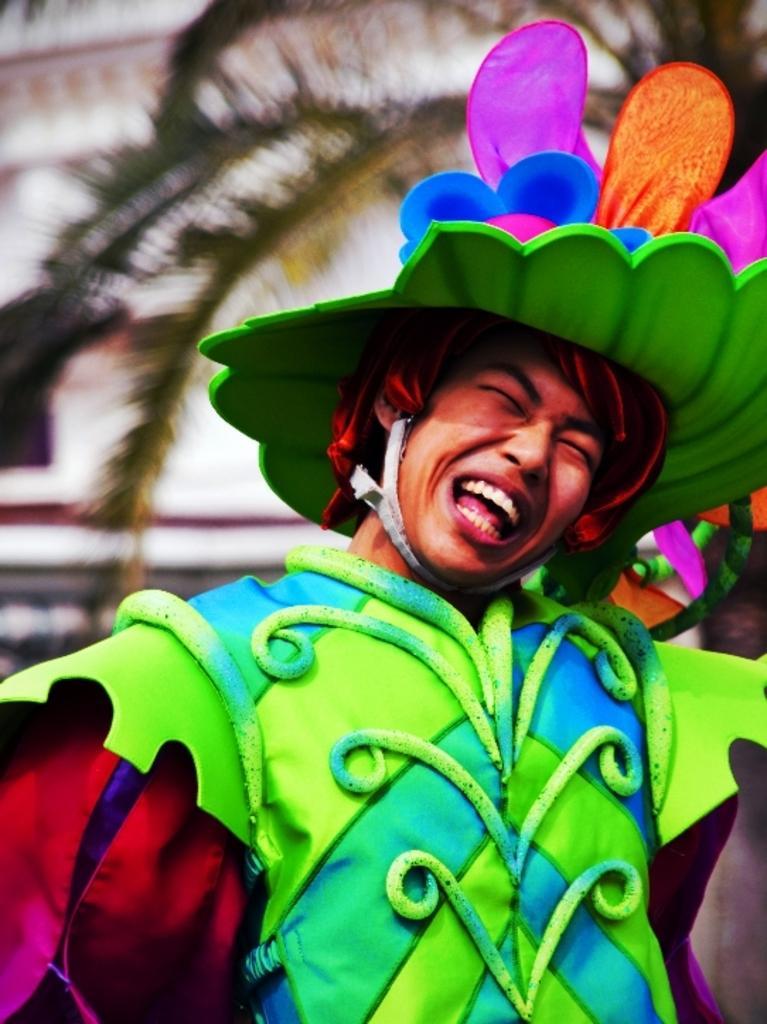Could you give a brief overview of what you see in this image? This picture shows a man standing and he wore colorful dress and colorful cap on his head and we see a tree and a building. 